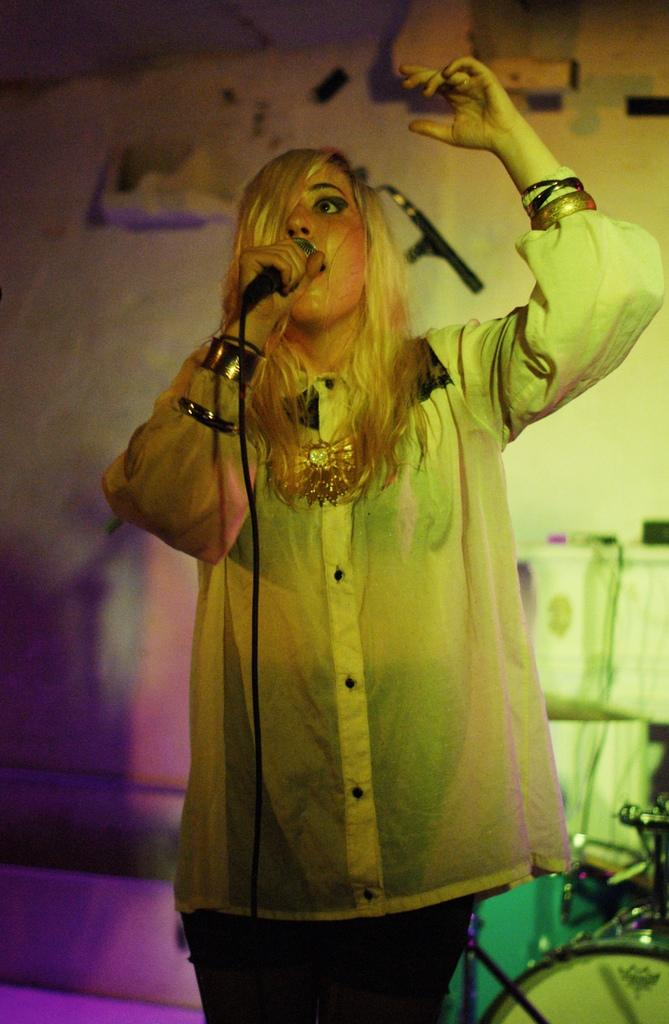Who is the main subject in the image? There is a lady in the image. What is the lady holding in the image? The lady is holding a microphone. What is the lady doing in the image? The lady is singing. What type of copper material can be seen in the image? There is no copper material present in the image. What kind of show is the lady performing in the image? The image does not provide information about a show or performance; it only shows the lady singing with a microphone. 